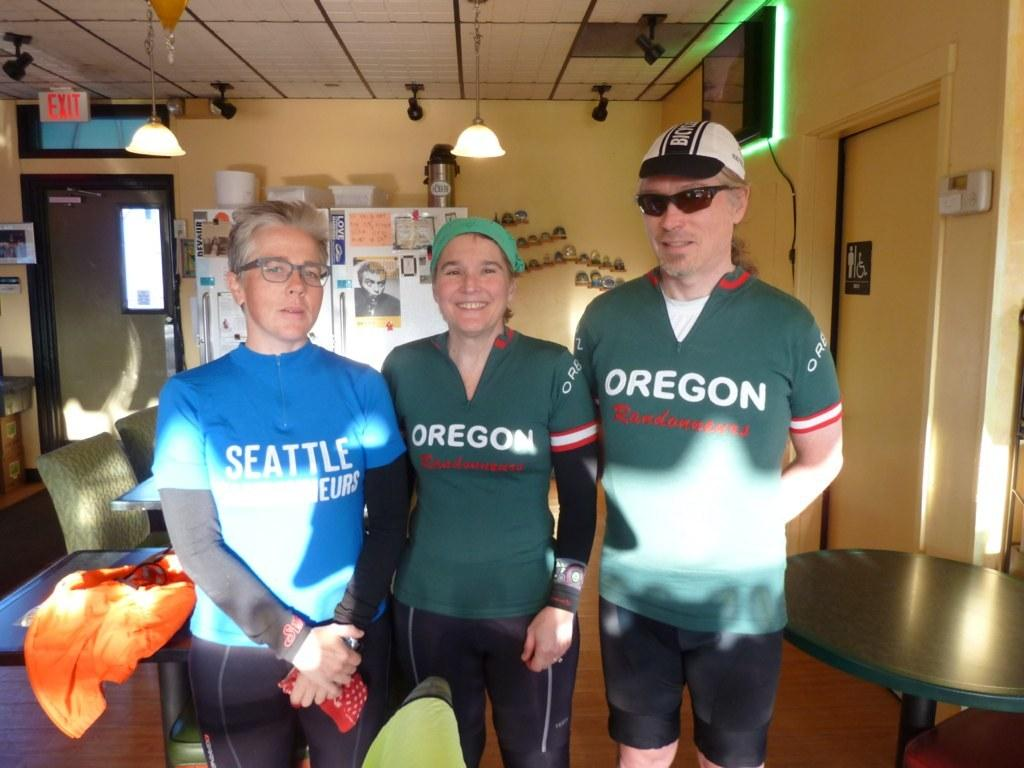How many people are in the image? There are three people in the image. What can be seen in the background of the image? Tables and chairs, lights, a sign board, a digital screen, and posters are present in the background. Can you describe the setting of the image based on the background? The background suggests a public or commercial area with seating and informational displays. Can you see a playground in the image? No, there is no playground present in the image. 